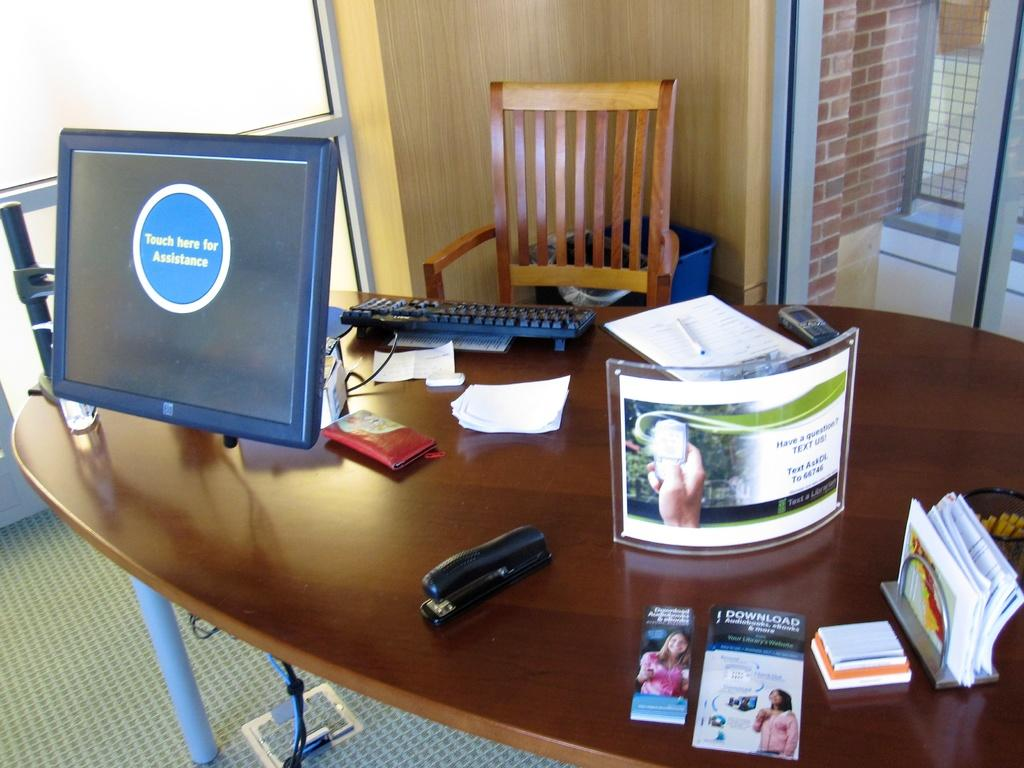What piece of furniture is present in the image? There is a table in the image. What is placed on the table? There is a system, a board, a book, papers, and a remote on the table. What type of seating is available in front of the table? There is a chair in front of the table. What can be seen through the window in the image? The facts provided do not mention anything about the window, so we cannot determine what can be seen through it. What is the price of the fish on the table? There is no fish present on the table in the image. How many stamps are on the board? There is no mention of stamps in the image, so we cannot determine how many are on the board. 